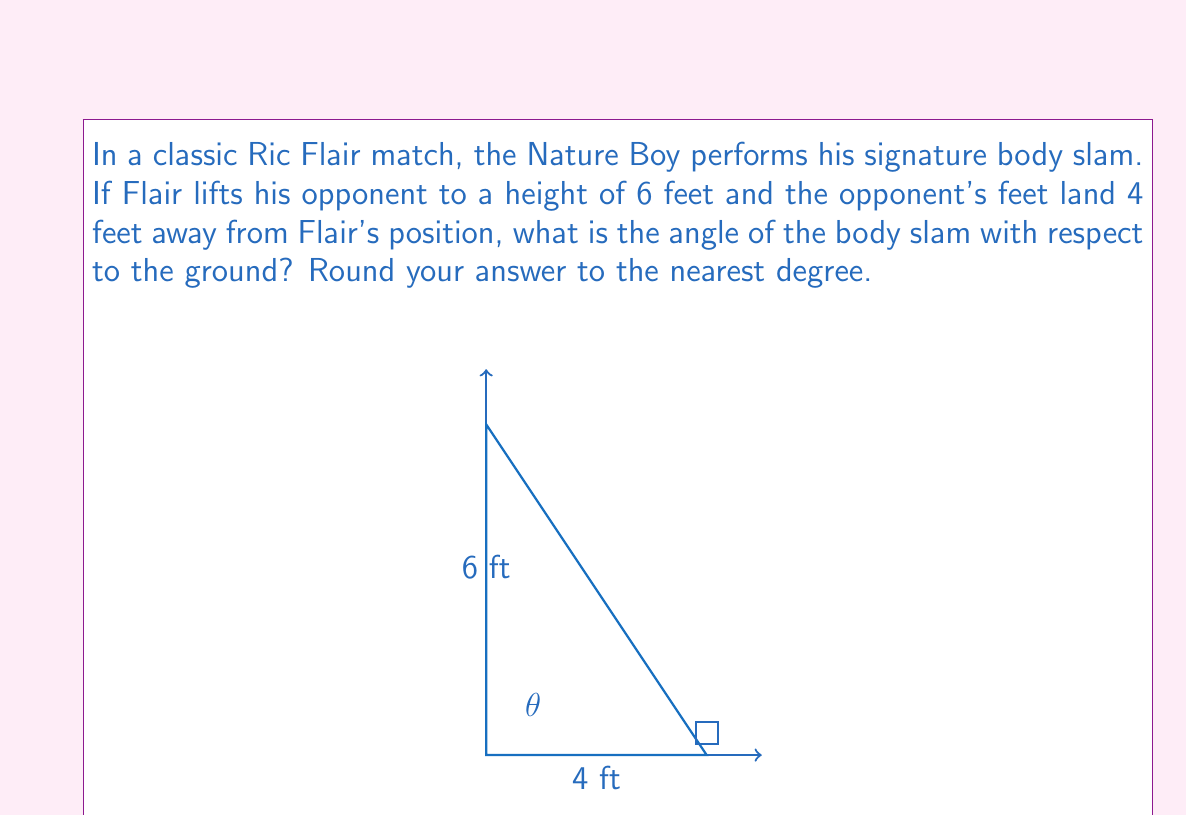Can you answer this question? Let's approach this step-by-step using trigonometry:

1) The situation forms a right triangle, where:
   - The height of the lift is the opposite side (6 feet)
   - The distance the opponent lands is the adjacent side (4 feet)
   - The angle we're looking for is the one between the ground and the path of the body slam

2) In a right triangle, we can use the tangent function to find this angle:

   $$\tan(\theta) = \frac{\text{opposite}}{\text{adjacent}}$$

3) Substituting our values:

   $$\tan(\theta) = \frac{6}{4} = 1.5$$

4) To find the angle, we need to use the inverse tangent (arctan or $\tan^{-1}$):

   $$\theta = \tan^{-1}(1.5)$$

5) Using a calculator or trigonometric tables:

   $$\theta \approx 56.31^\circ$$

6) Rounding to the nearest degree:

   $$\theta \approx 56^\circ$$

Therefore, the angle of Ric Flair's body slam with respect to the ground is approximately 56°.
Answer: $56^\circ$ 